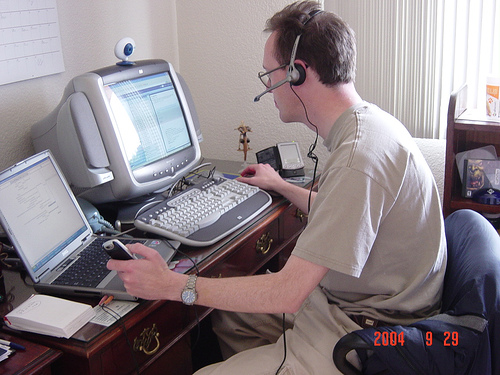<image>
Is the phone in the persons hand? Yes. The phone is contained within or inside the persons hand, showing a containment relationship. Where is the cell phone in relation to the man? Is it on the man? Yes. Looking at the image, I can see the cell phone is positioned on top of the man, with the man providing support. Where is the cellphone in relation to the laptop? Is it on the laptop? No. The cellphone is not positioned on the laptop. They may be near each other, but the cellphone is not supported by or resting on top of the laptop. 